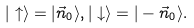Convert formula to latex. <formula><loc_0><loc_0><loc_500><loc_500>| \uparrow \rangle = | \vec { n } _ { 0 } \rangle , | \downarrow \rangle = | - \vec { n } _ { 0 } \rangle .</formula> 